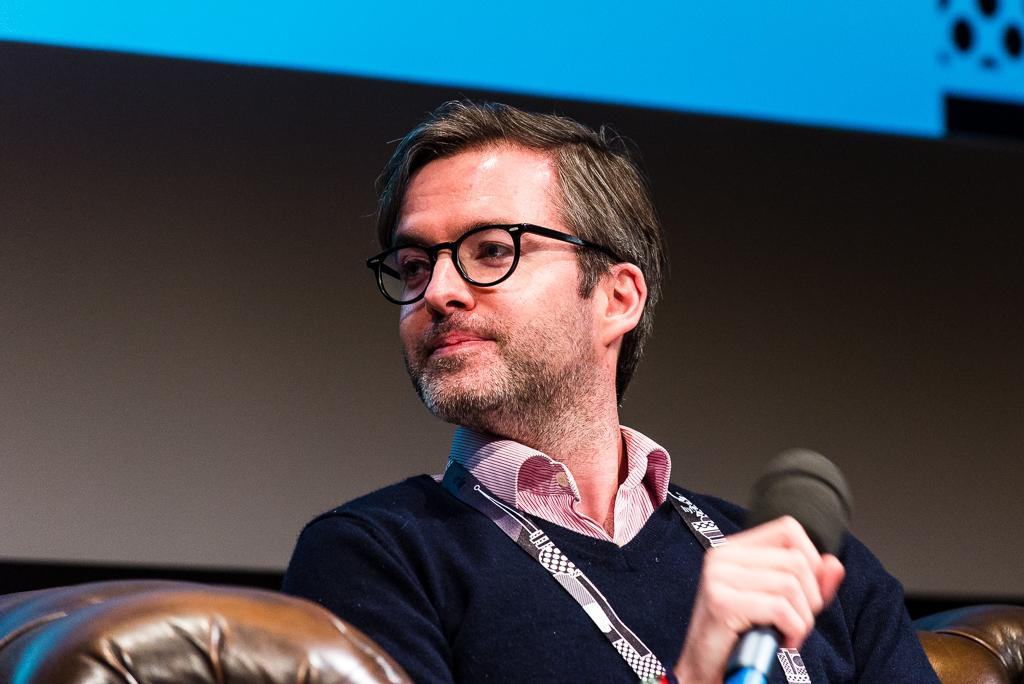Who is present in the image? There is a man in the image. What is the man doing in the image? The man is sitting on a sofa. What object is the man holding in his hand? The man is holding a mic in one of his hands. What type of book is the man reading on the sofa? There is no book present in the image; the man is holding a mic. What color is the toothbrush the man is using while sitting on the sofa? There is no toothbrush present in the image; the man is holding a mic. 